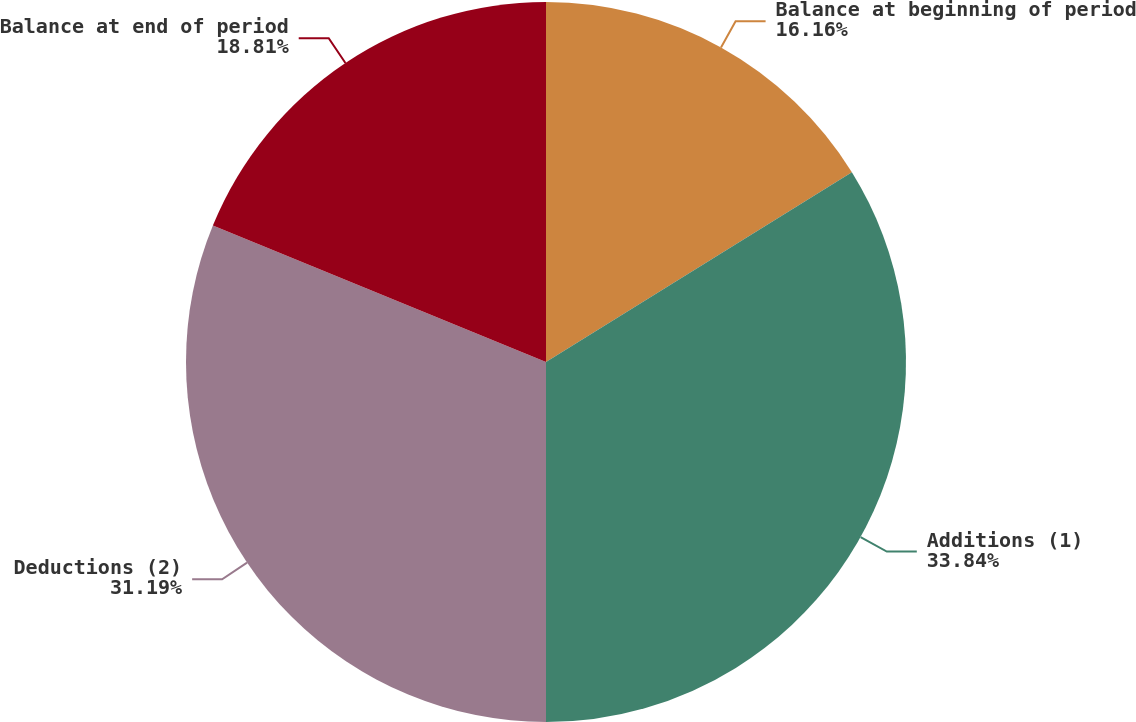Convert chart to OTSL. <chart><loc_0><loc_0><loc_500><loc_500><pie_chart><fcel>Balance at beginning of period<fcel>Additions (1)<fcel>Deductions (2)<fcel>Balance at end of period<nl><fcel>16.16%<fcel>33.84%<fcel>31.19%<fcel>18.81%<nl></chart> 